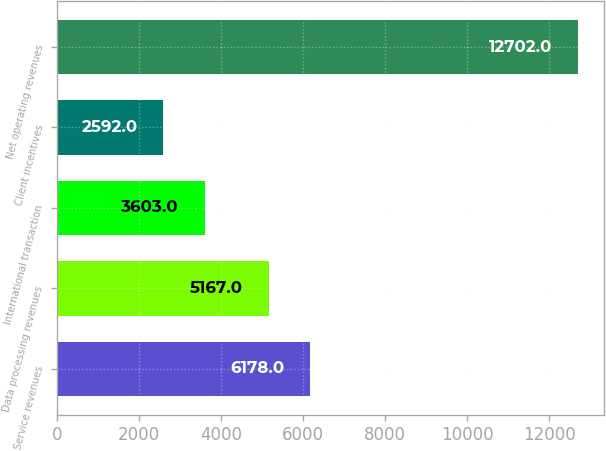<chart> <loc_0><loc_0><loc_500><loc_500><bar_chart><fcel>Service revenues<fcel>Data processing revenues<fcel>International transaction<fcel>Client incentives<fcel>Net operating revenues<nl><fcel>6178<fcel>5167<fcel>3603<fcel>2592<fcel>12702<nl></chart> 